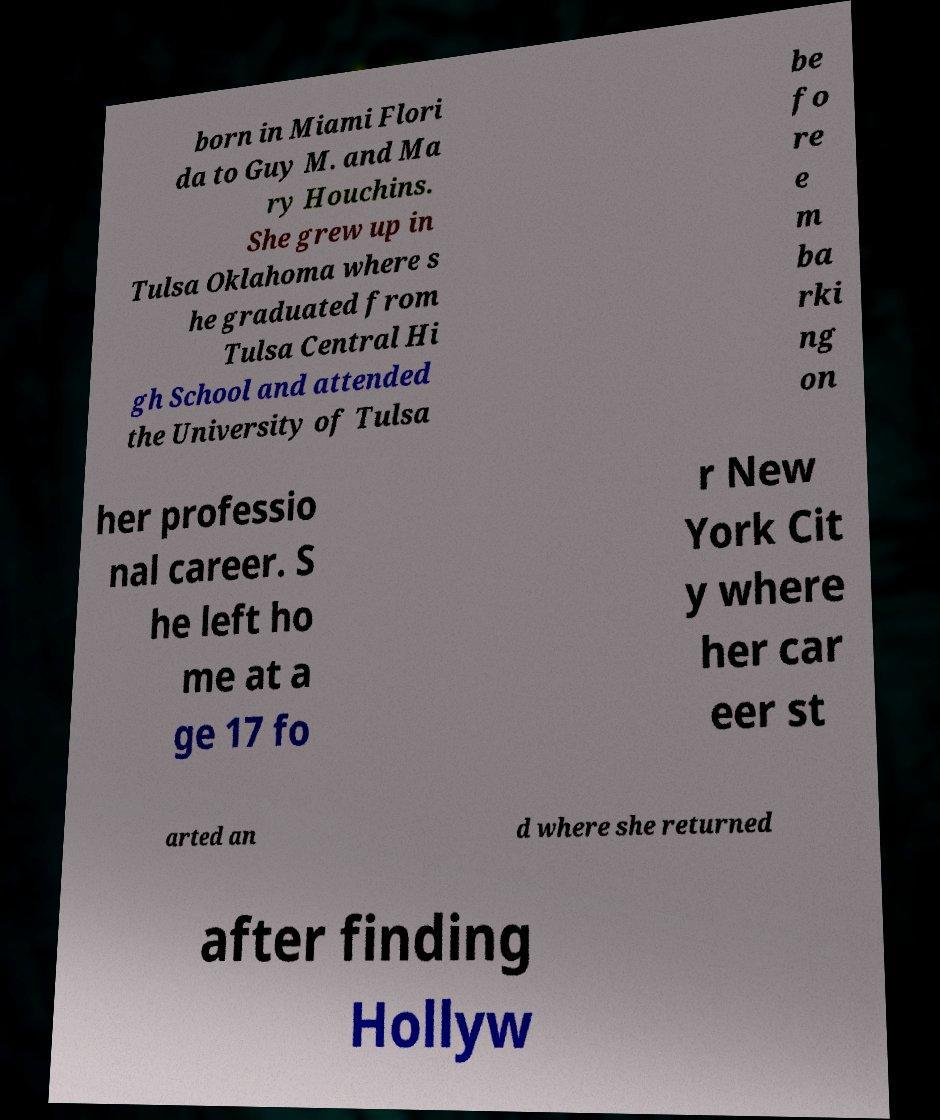There's text embedded in this image that I need extracted. Can you transcribe it verbatim? born in Miami Flori da to Guy M. and Ma ry Houchins. She grew up in Tulsa Oklahoma where s he graduated from Tulsa Central Hi gh School and attended the University of Tulsa be fo re e m ba rki ng on her professio nal career. S he left ho me at a ge 17 fo r New York Cit y where her car eer st arted an d where she returned after finding Hollyw 